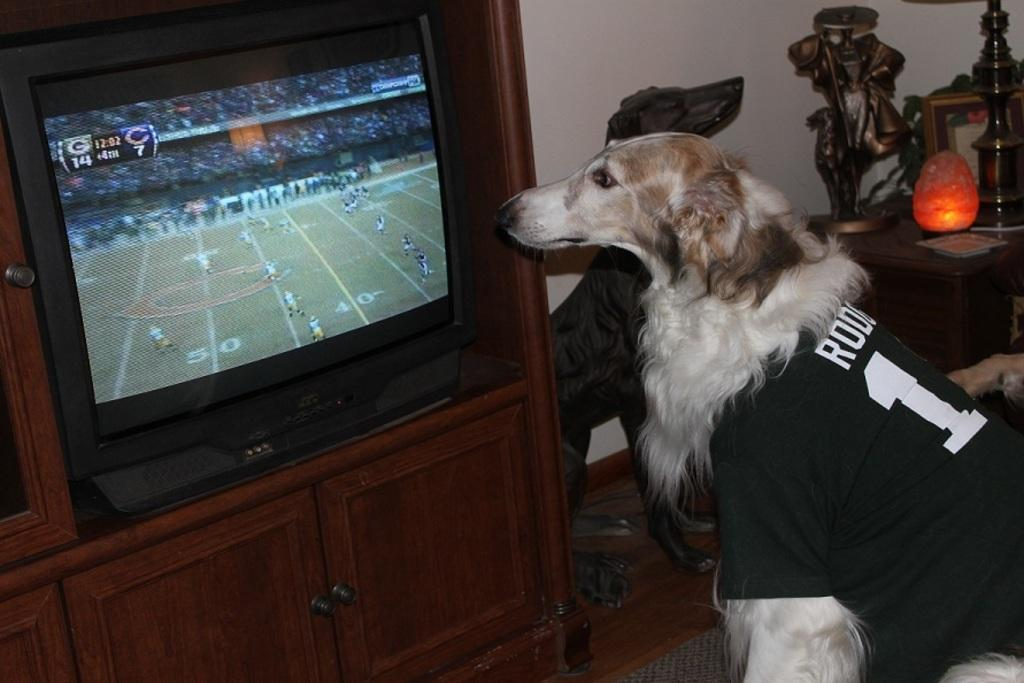What type of animal can be seen in the image? There is a dog in the image. Where is the dog located in relation to the television? The dog is in front of the television. What is located beside the television? There is a light and a frame beside the television. What else can be found on the table beside the television? There are other things on the table beside the television. What type of rod can be seen in the image? There is no rod present in the image. How does the dog twist its body in the image? The dog is not twisting its body in the image; it is standing in front of the television. 